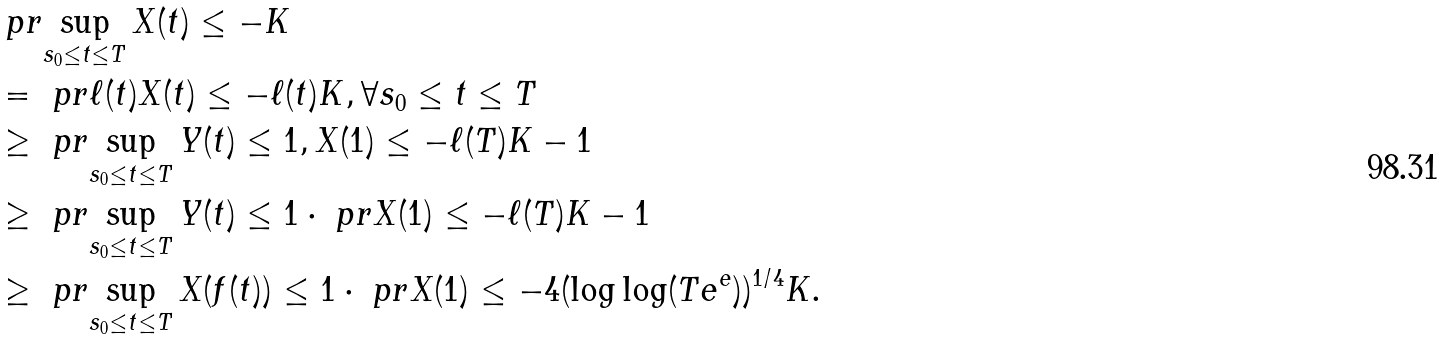<formula> <loc_0><loc_0><loc_500><loc_500>& \ p r { \sup _ { s _ { 0 } \leq t \leq T } X ( t ) \leq - K } \\ & = \ p r { \ell ( t ) X ( t ) \leq - \ell ( t ) K , \forall s _ { 0 } \leq t \leq T } \\ & \geq \ p r { \sup _ { s _ { 0 } \leq t \leq T } Y ( t ) \leq 1 , X ( 1 ) \leq - \ell ( T ) K - 1 } \\ & \geq \ p r { \sup _ { s _ { 0 } \leq t \leq T } Y ( t ) \leq 1 } \cdot \ p r { X ( 1 ) \leq - \ell ( T ) K - 1 } \\ & \geq \ p r { \sup _ { s _ { 0 } \leq t \leq T } X ( f ( t ) ) \leq 1 } \cdot \ p r { X ( 1 ) \leq - 4 ( \log \log ( T e ^ { e } ) ) ^ { 1 / 4 } K } .</formula> 